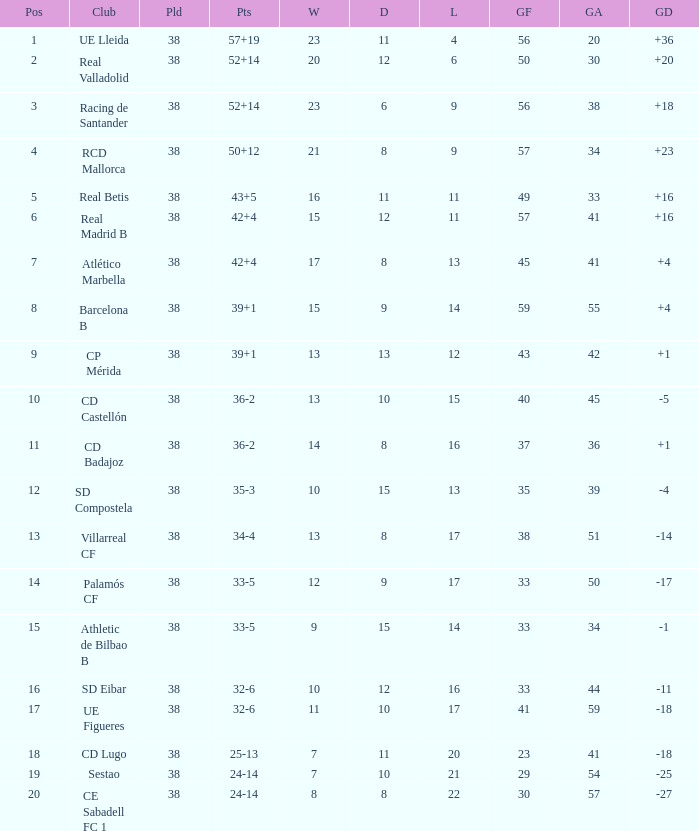Write the full table. {'header': ['Pos', 'Club', 'Pld', 'Pts', 'W', 'D', 'L', 'GF', 'GA', 'GD'], 'rows': [['1', 'UE Lleida', '38', '57+19', '23', '11', '4', '56', '20', '+36'], ['2', 'Real Valladolid', '38', '52+14', '20', '12', '6', '50', '30', '+20'], ['3', 'Racing de Santander', '38', '52+14', '23', '6', '9', '56', '38', '+18'], ['4', 'RCD Mallorca', '38', '50+12', '21', '8', '9', '57', '34', '+23'], ['5', 'Real Betis', '38', '43+5', '16', '11', '11', '49', '33', '+16'], ['6', 'Real Madrid B', '38', '42+4', '15', '12', '11', '57', '41', '+16'], ['7', 'Atlético Marbella', '38', '42+4', '17', '8', '13', '45', '41', '+4'], ['8', 'Barcelona B', '38', '39+1', '15', '9', '14', '59', '55', '+4'], ['9', 'CP Mérida', '38', '39+1', '13', '13', '12', '43', '42', '+1'], ['10', 'CD Castellón', '38', '36-2', '13', '10', '15', '40', '45', '-5'], ['11', 'CD Badajoz', '38', '36-2', '14', '8', '16', '37', '36', '+1'], ['12', 'SD Compostela', '38', '35-3', '10', '15', '13', '35', '39', '-4'], ['13', 'Villarreal CF', '38', '34-4', '13', '8', '17', '38', '51', '-14'], ['14', 'Palamós CF', '38', '33-5', '12', '9', '17', '33', '50', '-17'], ['15', 'Athletic de Bilbao B', '38', '33-5', '9', '15', '14', '33', '34', '-1'], ['16', 'SD Eibar', '38', '32-6', '10', '12', '16', '33', '44', '-11'], ['17', 'UE Figueres', '38', '32-6', '11', '10', '17', '41', '59', '-18'], ['18', 'CD Lugo', '38', '25-13', '7', '11', '20', '23', '41', '-18'], ['19', 'Sestao', '38', '24-14', '7', '10', '21', '29', '54', '-25'], ['20', 'CE Sabadell FC 1', '38', '24-14', '8', '8', '22', '30', '57', '-27']]} What is the lowest position with 32-6 points and less then 59 goals when there are more than 38 played? None. 